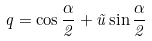<formula> <loc_0><loc_0><loc_500><loc_500>q = \cos \frac { \alpha } { 2 } + \vec { u } \sin \frac { \alpha } { 2 }</formula> 